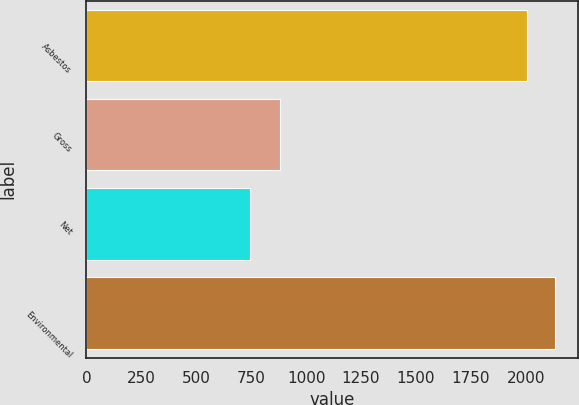Convert chart to OTSL. <chart><loc_0><loc_0><loc_500><loc_500><bar_chart><fcel>Asbestos<fcel>Gross<fcel>Net<fcel>Environmental<nl><fcel>2006<fcel>882<fcel>745<fcel>2132.1<nl></chart> 